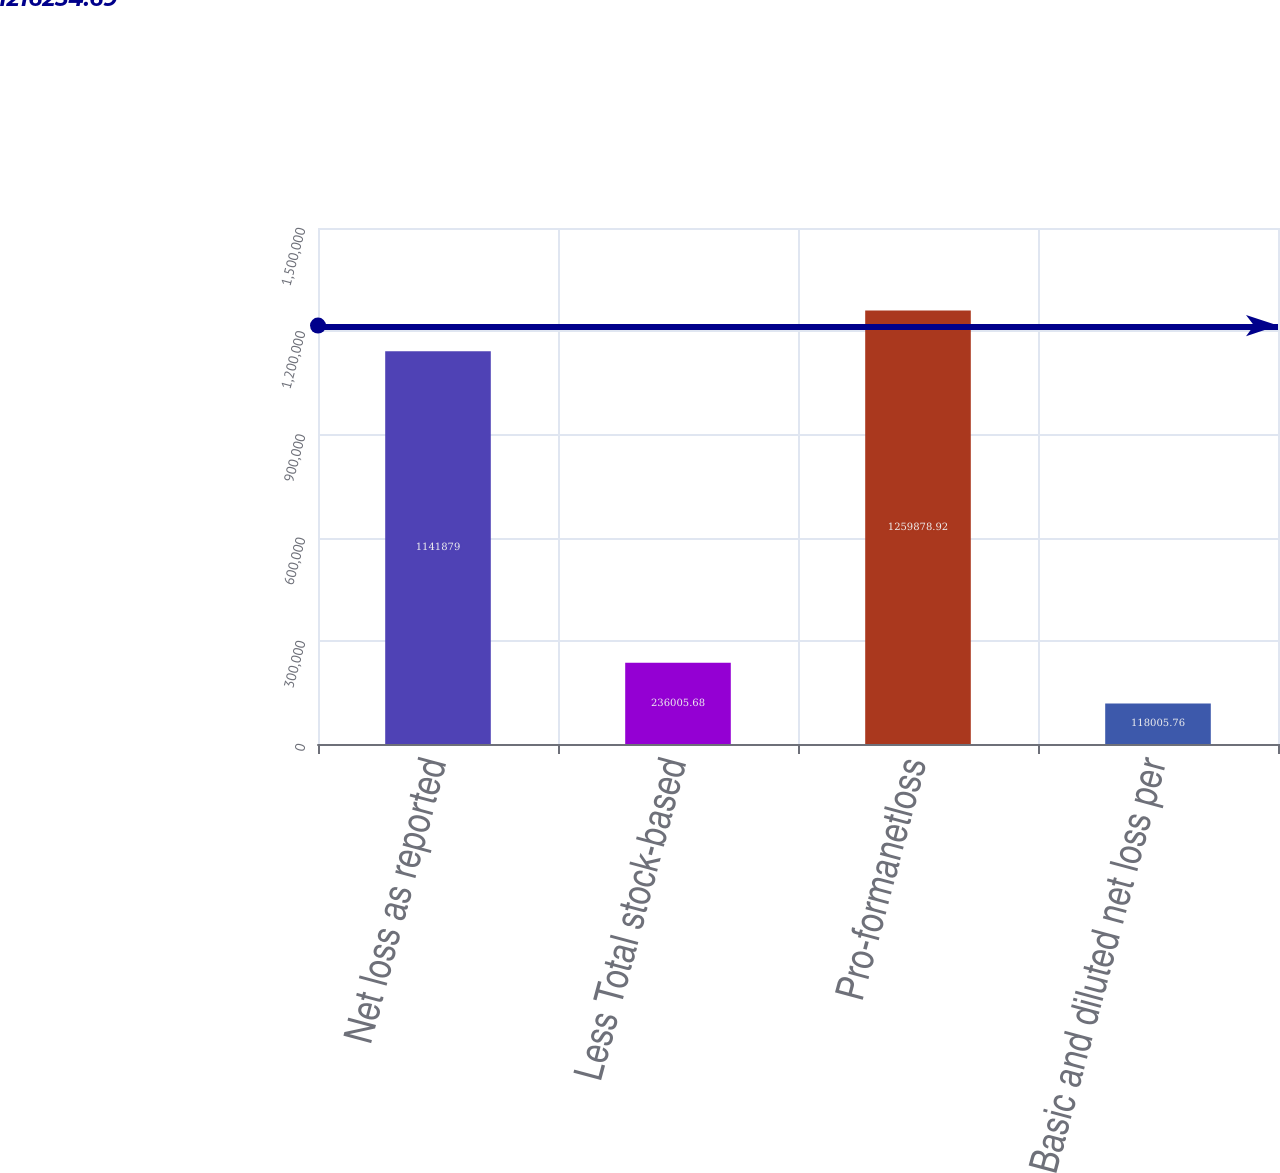Convert chart to OTSL. <chart><loc_0><loc_0><loc_500><loc_500><bar_chart><fcel>Net loss as reported<fcel>Less Total stock-based<fcel>Pro-formanetloss<fcel>Basic and diluted net loss per<nl><fcel>1.14188e+06<fcel>236006<fcel>1.25988e+06<fcel>118006<nl></chart> 